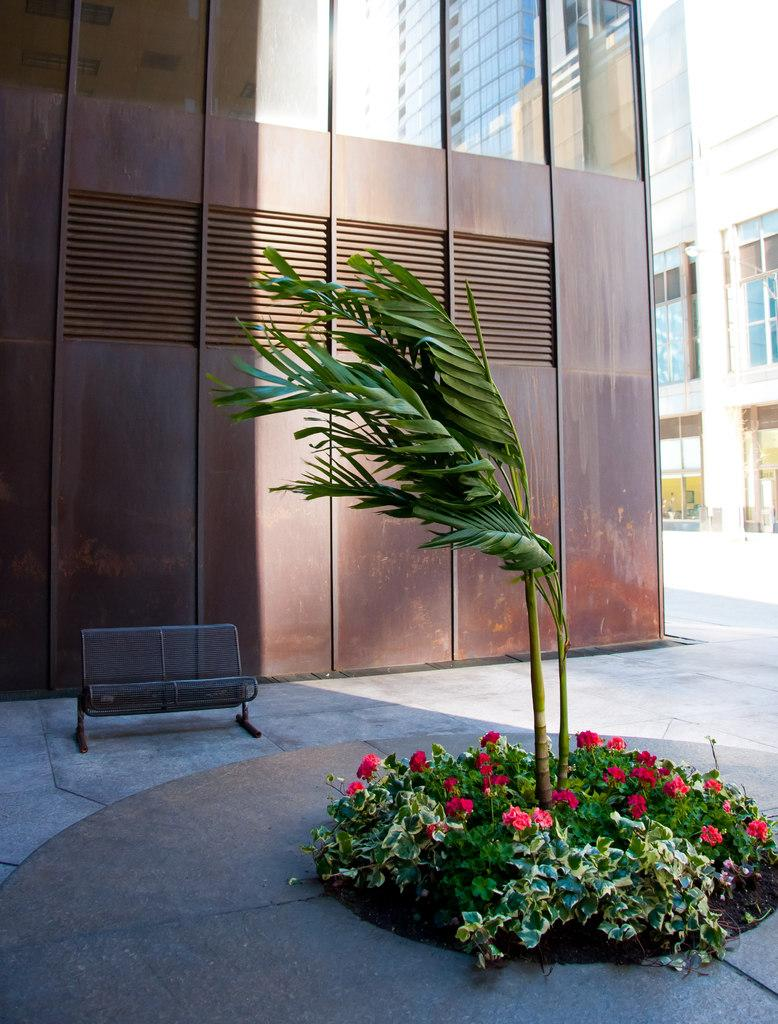What is the main subject in the center of the image? There is a plant in the center of the image. What other types of vegetation can be seen in the image? There are shrubs and flowers in the image. Where is the bench located in the image? The bench is on the left side of the image. What can be seen in the background of the image? There are buildings in the background of the image. What scent can be detected from the wilderness in the image? There is no wilderness present in the image, so it is not possible to detect a scent from it. 